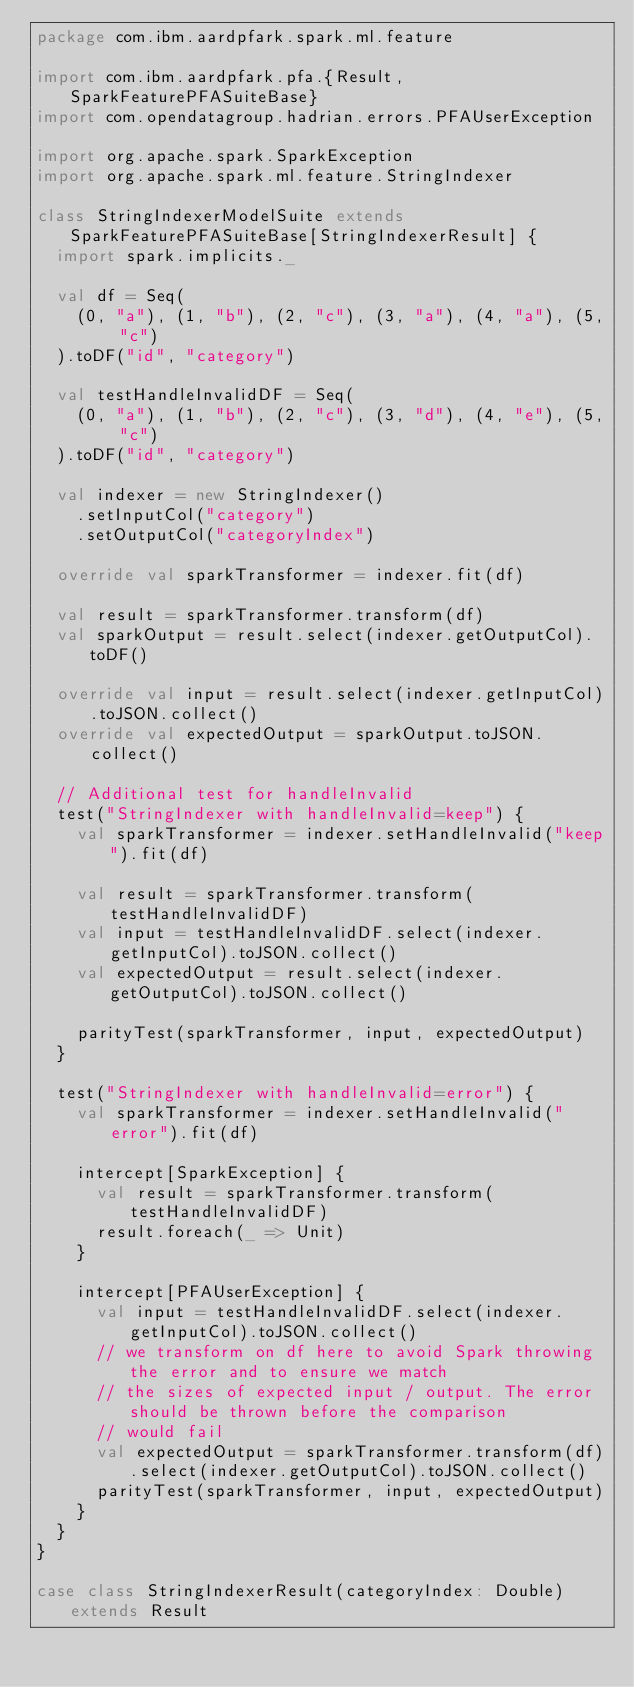<code> <loc_0><loc_0><loc_500><loc_500><_Scala_>package com.ibm.aardpfark.spark.ml.feature

import com.ibm.aardpfark.pfa.{Result, SparkFeaturePFASuiteBase}
import com.opendatagroup.hadrian.errors.PFAUserException

import org.apache.spark.SparkException
import org.apache.spark.ml.feature.StringIndexer

class StringIndexerModelSuite extends SparkFeaturePFASuiteBase[StringIndexerResult] {
  import spark.implicits._

  val df = Seq(
    (0, "a"), (1, "b"), (2, "c"), (3, "a"), (4, "a"), (5, "c")
  ).toDF("id", "category")

  val testHandleInvalidDF = Seq(
    (0, "a"), (1, "b"), (2, "c"), (3, "d"), (4, "e"), (5, "c")
  ).toDF("id", "category")

  val indexer = new StringIndexer()
    .setInputCol("category")
    .setOutputCol("categoryIndex")

  override val sparkTransformer = indexer.fit(df)

  val result = sparkTransformer.transform(df)
  val sparkOutput = result.select(indexer.getOutputCol).toDF()

  override val input = result.select(indexer.getInputCol).toJSON.collect()
  override val expectedOutput = sparkOutput.toJSON.collect()

  // Additional test for handleInvalid
  test("StringIndexer with handleInvalid=keep") {
    val sparkTransformer = indexer.setHandleInvalid("keep").fit(df)

    val result = sparkTransformer.transform(testHandleInvalidDF)
    val input = testHandleInvalidDF.select(indexer.getInputCol).toJSON.collect()
    val expectedOutput = result.select(indexer.getOutputCol).toJSON.collect()

    parityTest(sparkTransformer, input, expectedOutput)
  }

  test("StringIndexer with handleInvalid=error") {
    val sparkTransformer = indexer.setHandleInvalid("error").fit(df)

    intercept[SparkException] {
      val result = sparkTransformer.transform(testHandleInvalidDF)
      result.foreach(_ => Unit)
    }

    intercept[PFAUserException] {
      val input = testHandleInvalidDF.select(indexer.getInputCol).toJSON.collect()
      // we transform on df here to avoid Spark throwing the error and to ensure we match
      // the sizes of expected input / output. The error should be thrown before the comparison
      // would fail
      val expectedOutput = sparkTransformer.transform(df).select(indexer.getOutputCol).toJSON.collect()
      parityTest(sparkTransformer, input, expectedOutput)
    }
  }
}

case class StringIndexerResult(categoryIndex: Double) extends Result</code> 